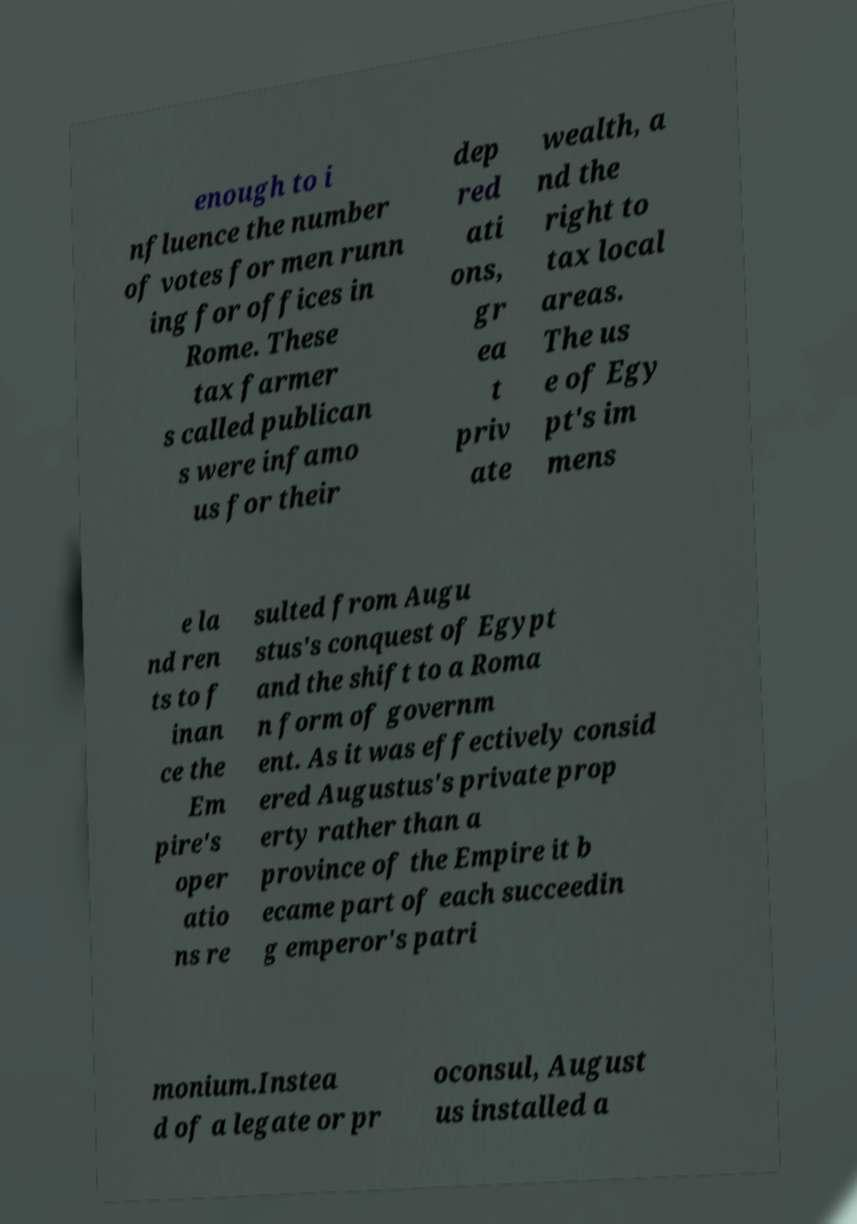Can you accurately transcribe the text from the provided image for me? enough to i nfluence the number of votes for men runn ing for offices in Rome. These tax farmer s called publican s were infamo us for their dep red ati ons, gr ea t priv ate wealth, a nd the right to tax local areas. The us e of Egy pt's im mens e la nd ren ts to f inan ce the Em pire's oper atio ns re sulted from Augu stus's conquest of Egypt and the shift to a Roma n form of governm ent. As it was effectively consid ered Augustus's private prop erty rather than a province of the Empire it b ecame part of each succeedin g emperor's patri monium.Instea d of a legate or pr oconsul, August us installed a 